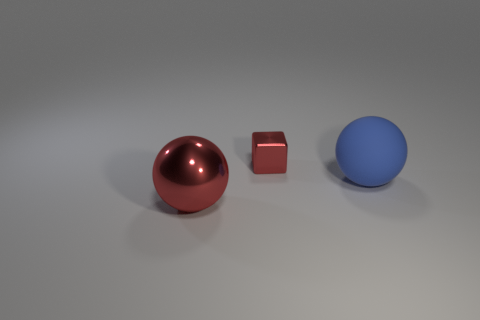What materials do the objects seem to be made of? The objects in the image exhibit reflective properties suggesting they might be made of materials such as polished metal or plastic. The large red sphere and the block seem to have a metallic sheen, while the blue ball appears to have a matte finish, possibly indicating a different type of material or surface texture. 